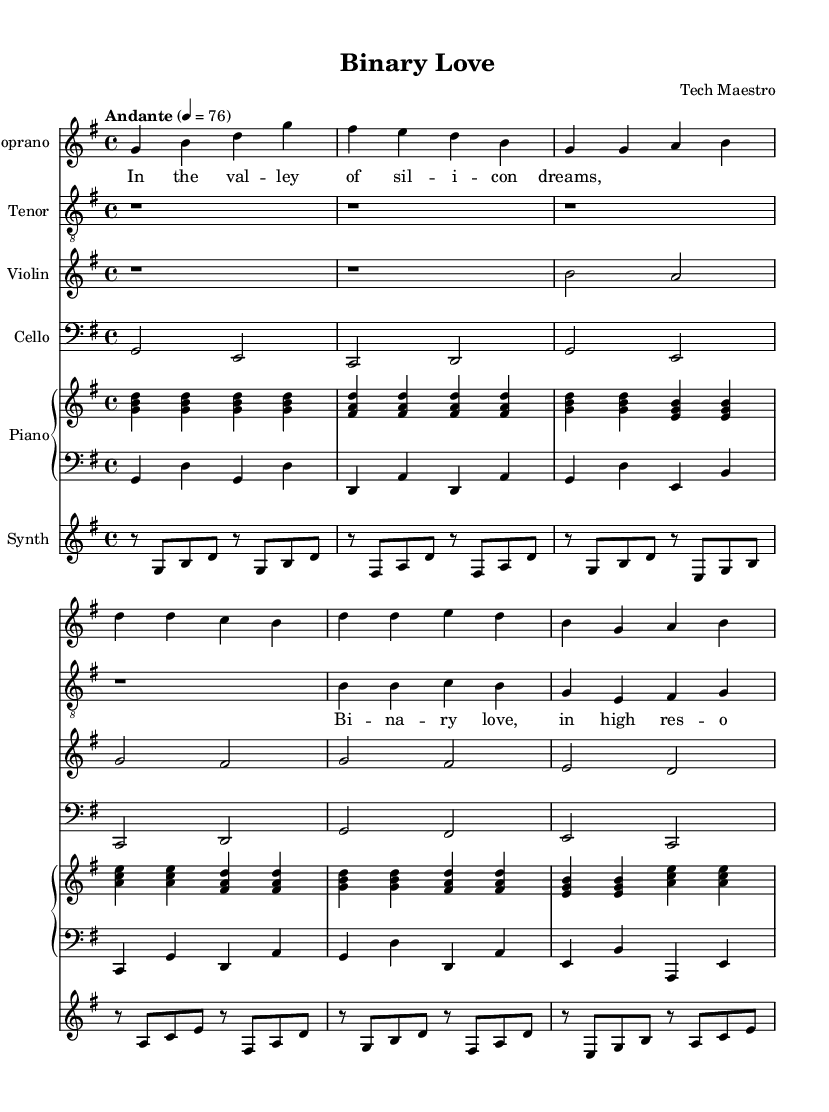What is the key signature of this music? The key signature is indicated at the beginning of the staff, which shows one sharp. This corresponds to the key of G major.
Answer: G major What is the time signature of this music? The time signature is indicated right after the key signature at the beginning. It shows "4/4," meaning there are four beats in each measure and a quarter note gets one beat.
Answer: 4/4 What is the tempo marking given in this piece? The tempo marking is specified as "Andante" with a metronome marking of 76. "Andante" suggests a moderately slow tempo.
Answer: Andante, 76 What instruments are included in this score? By closely examining the different staves at the beginning of the score, we can see the instruments listed include Soprano, Tenor, Violin, Cello, Piano, and Synthesizer.
Answer: Soprano, Tenor, Violin, Cello, Piano, Synthesizer How many measures are included in the chorus section? By counting the measures from the beginning of the chorus section outlined in the score, we can find that there are 4 measures listed.
Answer: 4 What is the main theme expressed in the title of the opera? The title of the opera, "Binary Love," reflects the central theme, which relates to tech and emotional connections, suggesting a juxtaposition of technology and romance.
Answer: Binary Love What type of opera is represented in this piece, based on the setting and title? This piece is identified as a Romantic opera due to its emotional themes and narrative, set in the context of Silicon Valley during the tech boom of the 1990s, integrating modern and traditional elements.
Answer: Romantic opera 